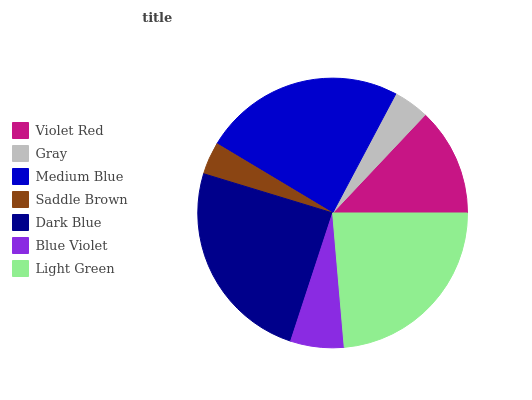Is Saddle Brown the minimum?
Answer yes or no. Yes. Is Dark Blue the maximum?
Answer yes or no. Yes. Is Gray the minimum?
Answer yes or no. No. Is Gray the maximum?
Answer yes or no. No. Is Violet Red greater than Gray?
Answer yes or no. Yes. Is Gray less than Violet Red?
Answer yes or no. Yes. Is Gray greater than Violet Red?
Answer yes or no. No. Is Violet Red less than Gray?
Answer yes or no. No. Is Violet Red the high median?
Answer yes or no. Yes. Is Violet Red the low median?
Answer yes or no. Yes. Is Gray the high median?
Answer yes or no. No. Is Saddle Brown the low median?
Answer yes or no. No. 